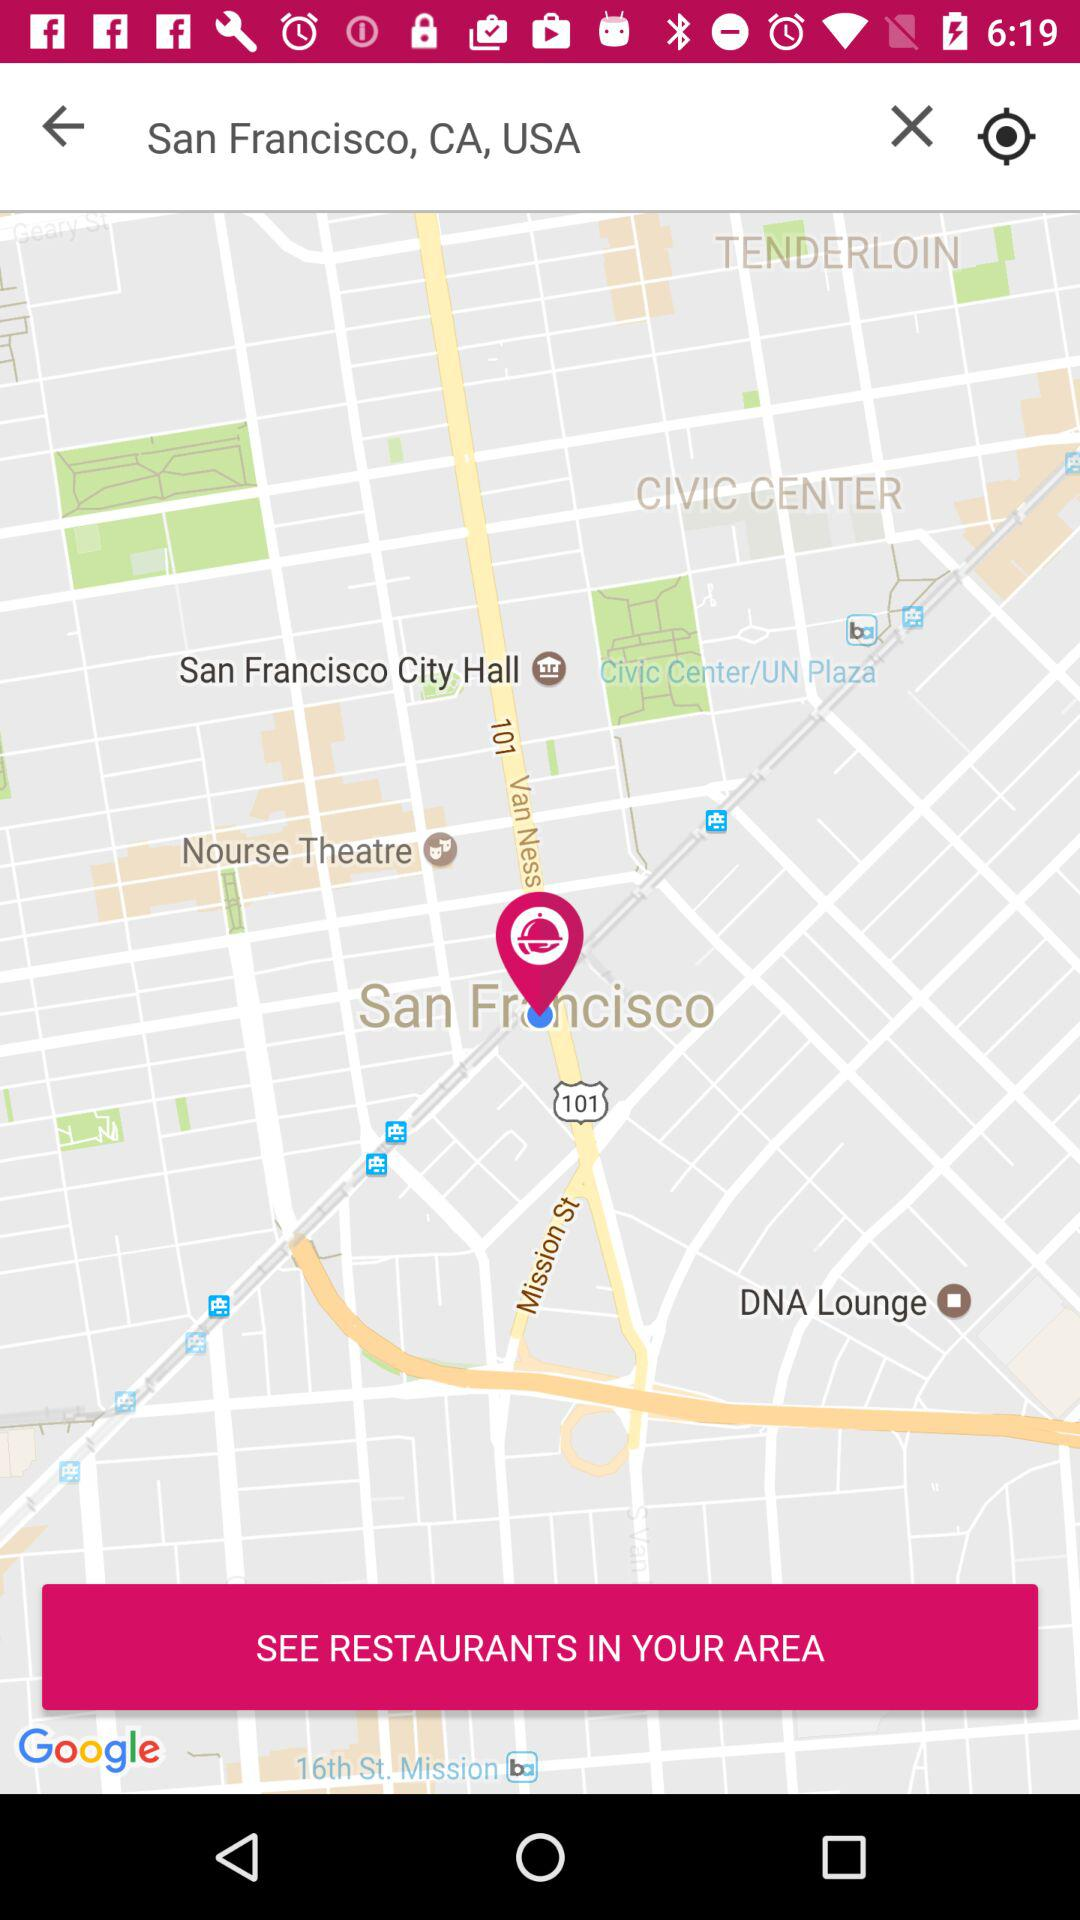What location is shown? The shown location is San Francisco, CA, USA. 